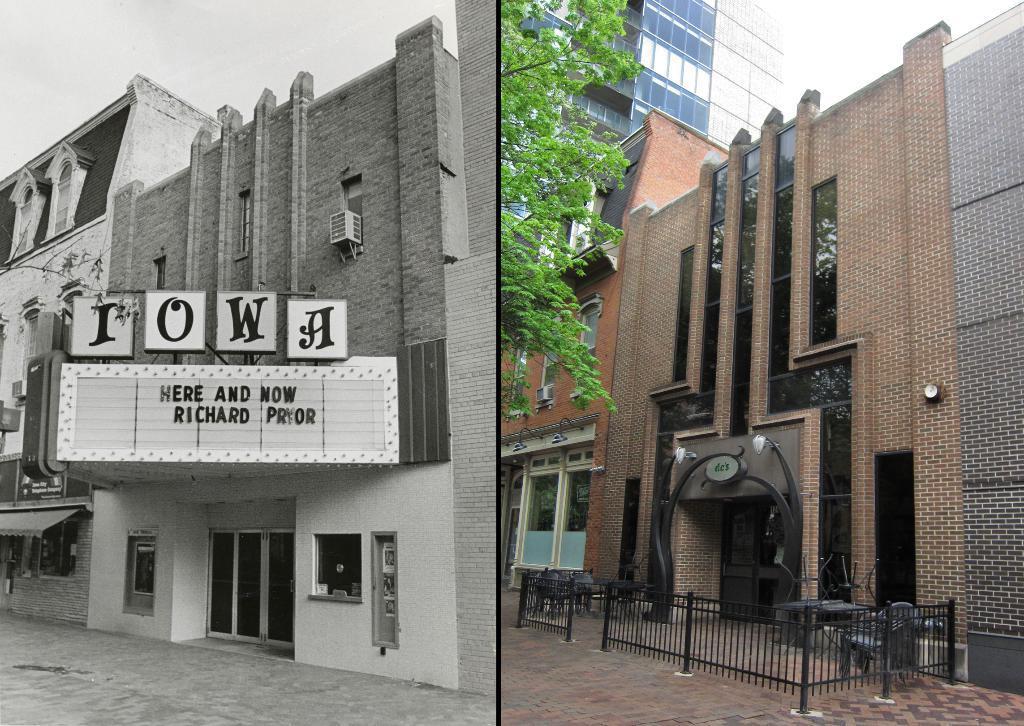Please provide a concise description of this image. It is a photo collage, on the left side, there is a building with a name on it. On the right side there is a building with glasses, there is a tree in this image. 